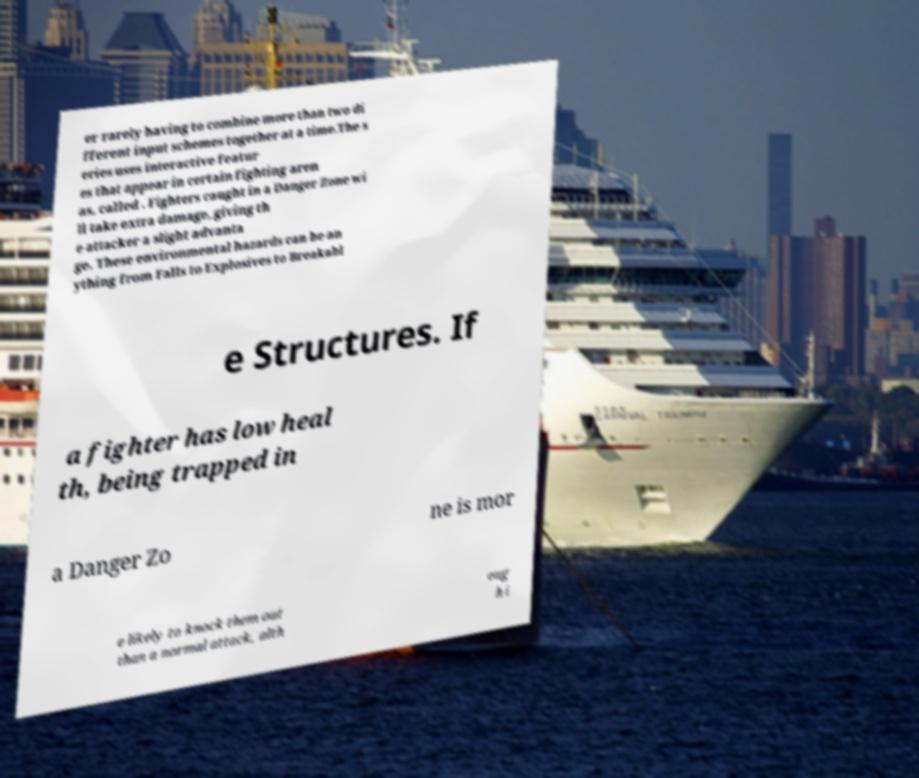Please identify and transcribe the text found in this image. er rarely having to combine more than two di fferent input schemes together at a time.The s eries uses interactive featur es that appear in certain fighting aren as, called . Fighters caught in a Danger Zone wi ll take extra damage, giving th e attacker a slight advanta ge. These environmental hazards can be an ything from Falls to Explosives to Breakabl e Structures. If a fighter has low heal th, being trapped in a Danger Zo ne is mor e likely to knock them out than a normal attack, alth oug h i 